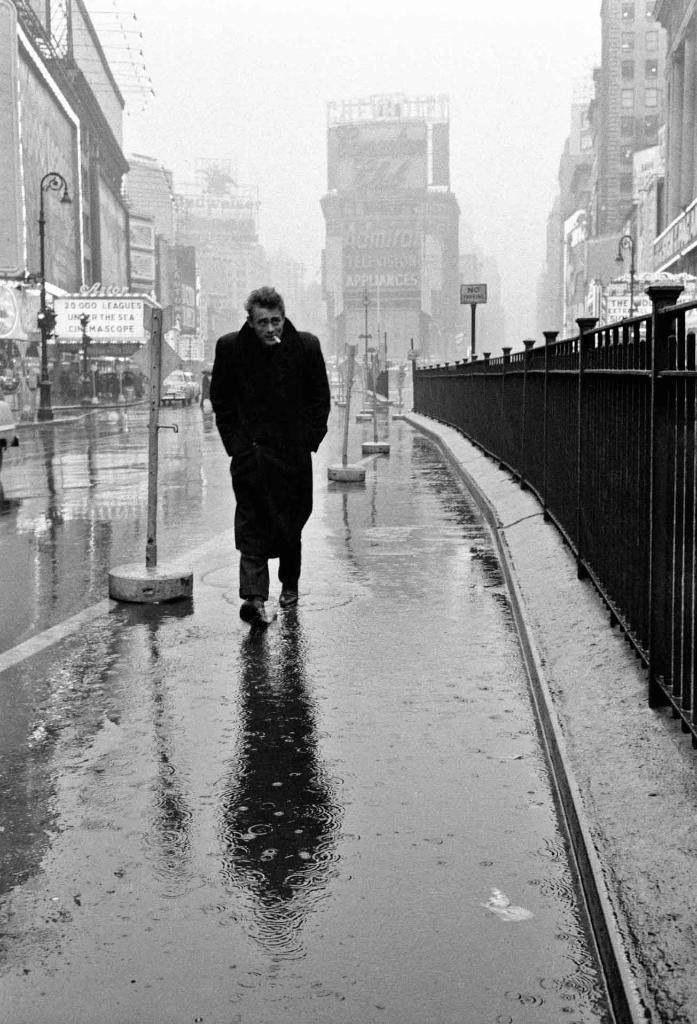In one or two sentences, can you explain what this image depicts? In the center of the image there is a person walking on the road. On the right side of the image we can see fencing and buildings. On the left side of the image we can see traffic signals, poles, vehicles and buildings. In the background we can see buildings and sky. 